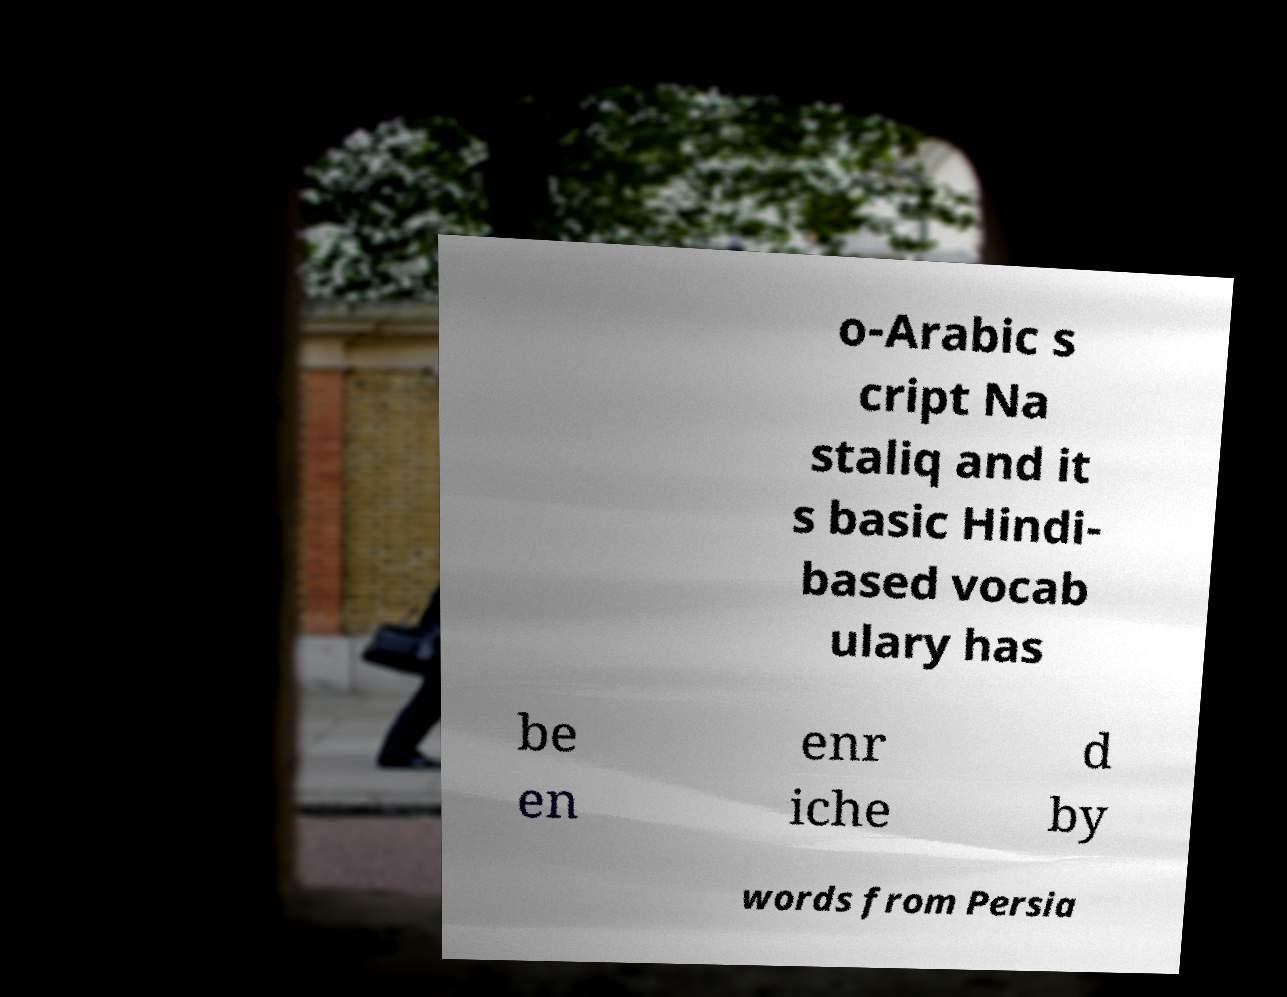There's text embedded in this image that I need extracted. Can you transcribe it verbatim? o-Arabic s cript Na staliq and it s basic Hindi- based vocab ulary has be en enr iche d by words from Persia 